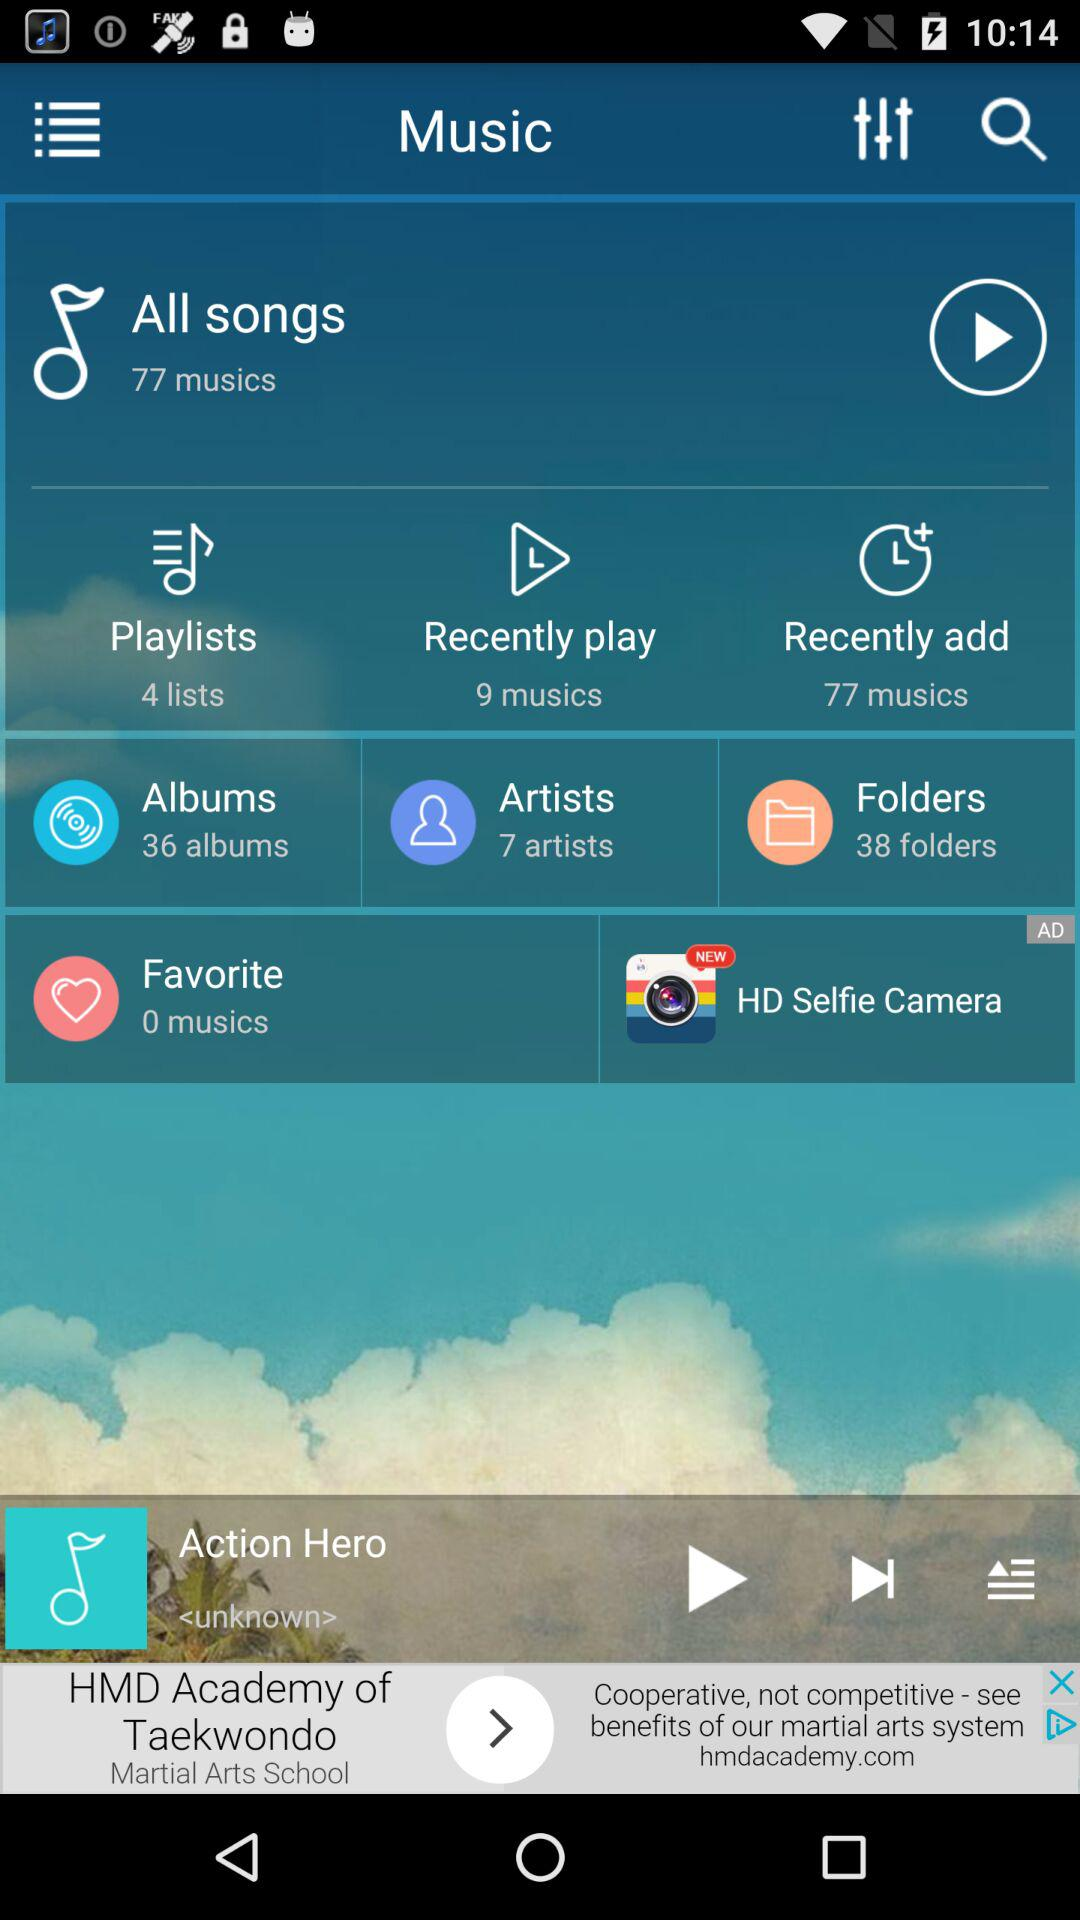How many folders are there? There are 38 folders. 